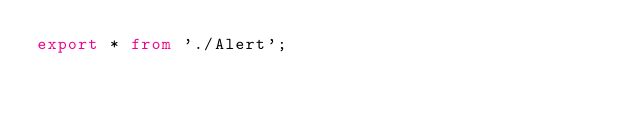Convert code to text. <code><loc_0><loc_0><loc_500><loc_500><_TypeScript_>export * from './Alert';
</code> 